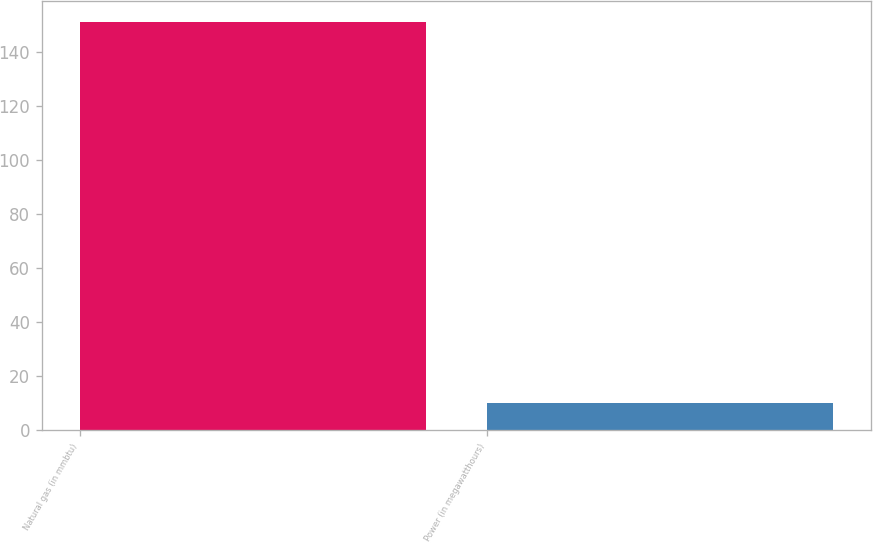<chart> <loc_0><loc_0><loc_500><loc_500><bar_chart><fcel>Natural gas (in mmbtu)<fcel>Power (in megawatthours)<nl><fcel>151<fcel>10<nl></chart> 